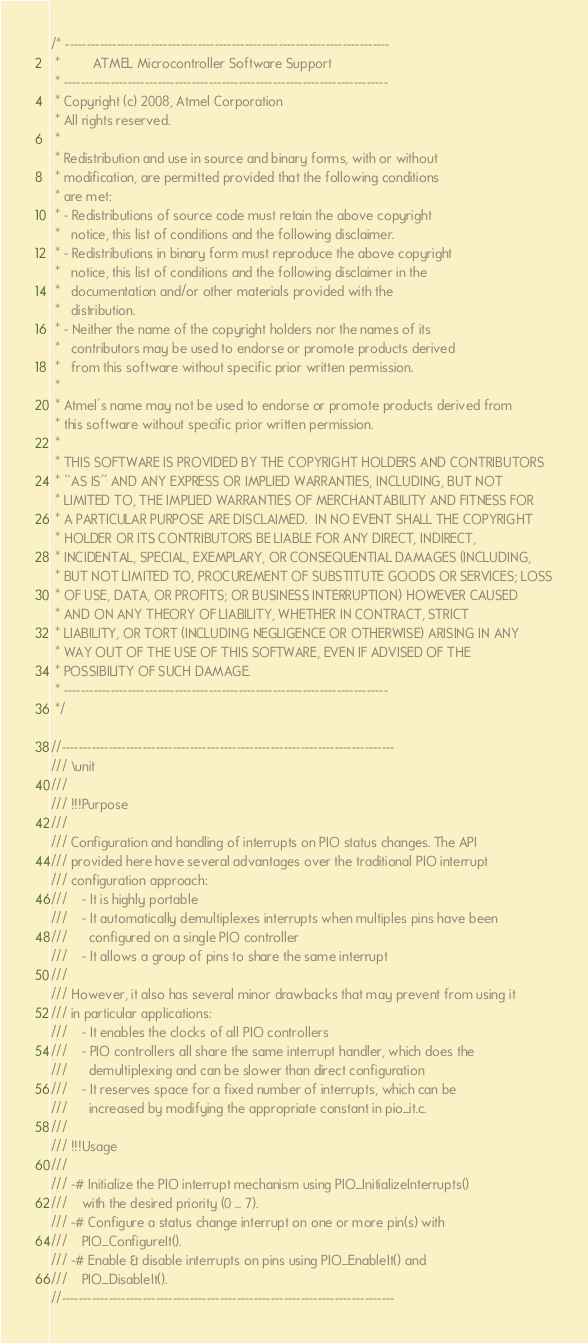Convert code to text. <code><loc_0><loc_0><loc_500><loc_500><_C_>/* ----------------------------------------------------------------------------
 *         ATMEL Microcontroller Software Support 
 * ----------------------------------------------------------------------------
 * Copyright (c) 2008, Atmel Corporation
 * All rights reserved.
 *
 * Redistribution and use in source and binary forms, with or without
 * modification, are permitted provided that the following conditions
 * are met:
 * - Redistributions of source code must retain the above copyright
 *   notice, this list of conditions and the following disclaimer.
 * - Redistributions in binary form must reproduce the above copyright
 *   notice, this list of conditions and the following disclaimer in the
 *   documentation and/or other materials provided with the
 *   distribution.
 * - Neither the name of the copyright holders nor the names of its
 *   contributors may be used to endorse or promote products derived
 *   from this software without specific prior written permission.
 *
 * Atmel's name may not be used to endorse or promote products derived from
 * this software without specific prior written permission.
 *
 * THIS SOFTWARE IS PROVIDED BY THE COPYRIGHT HOLDERS AND CONTRIBUTORS
 * ``AS IS'' AND ANY EXPRESS OR IMPLIED WARRANTIES, INCLUDING, BUT NOT
 * LIMITED TO, THE IMPLIED WARRANTIES OF MERCHANTABILITY AND FITNESS FOR
 * A PARTICULAR PURPOSE ARE DISCLAIMED.  IN NO EVENT SHALL THE COPYRIGHT
 * HOLDER OR ITS CONTRIBUTORS BE LIABLE FOR ANY DIRECT, INDIRECT,
 * INCIDENTAL, SPECIAL, EXEMPLARY, OR CONSEQUENTIAL DAMAGES (INCLUDING,
 * BUT NOT LIMITED TO, PROCUREMENT OF SUBSTITUTE GOODS OR SERVICES; LOSS
 * OF USE, DATA, OR PROFITS; OR BUSINESS INTERRUPTION) HOWEVER CAUSED
 * AND ON ANY THEORY OF LIABILITY, WHETHER IN CONTRACT, STRICT
 * LIABILITY, OR TORT (INCLUDING NEGLIGENCE OR OTHERWISE) ARISING IN ANY
 * WAY OUT OF THE USE OF THIS SOFTWARE, EVEN IF ADVISED OF THE
 * POSSIBILITY OF SUCH DAMAGE.
 * ----------------------------------------------------------------------------
 */

//------------------------------------------------------------------------------
/// \unit
///
/// !!!Purpose
/// 
/// Configuration and handling of interrupts on PIO status changes. The API
/// provided here have several advantages over the traditional PIO interrupt
/// configuration approach:
///    - It is highly portable
///    - It automatically demultiplexes interrupts when multiples pins have been
///      configured on a single PIO controller
///    - It allows a group of pins to share the same interrupt
/// 
/// However, it also has several minor drawbacks that may prevent from using it
/// in particular applications:
///    - It enables the clocks of all PIO controllers
///    - PIO controllers all share the same interrupt handler, which does the
///      demultiplexing and can be slower than direct configuration
///    - It reserves space for a fixed number of interrupts, which can be
///      increased by modifying the appropriate constant in pio_it.c.
///
/// !!!Usage
/// 
/// -# Initialize the PIO interrupt mechanism using PIO_InitializeInterrupts()
///    with the desired priority (0 ... 7).
/// -# Configure a status change interrupt on one or more pin(s) with
///    PIO_ConfigureIt().
/// -# Enable & disable interrupts on pins using PIO_EnableIt() and
///    PIO_DisableIt().
//------------------------------------------------------------------------------
</code> 